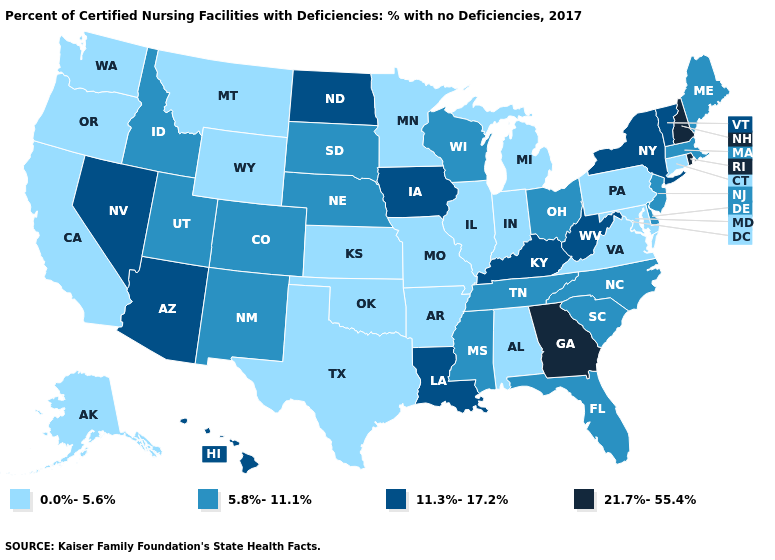Among the states that border Pennsylvania , which have the lowest value?
Quick response, please. Maryland. What is the lowest value in the USA?
Write a very short answer. 0.0%-5.6%. What is the value of West Virginia?
Keep it brief. 11.3%-17.2%. Does Alaska have the same value as Minnesota?
Be succinct. Yes. Does New York have the highest value in the Northeast?
Keep it brief. No. Which states have the lowest value in the USA?
Short answer required. Alabama, Alaska, Arkansas, California, Connecticut, Illinois, Indiana, Kansas, Maryland, Michigan, Minnesota, Missouri, Montana, Oklahoma, Oregon, Pennsylvania, Texas, Virginia, Washington, Wyoming. Name the states that have a value in the range 5.8%-11.1%?
Write a very short answer. Colorado, Delaware, Florida, Idaho, Maine, Massachusetts, Mississippi, Nebraska, New Jersey, New Mexico, North Carolina, Ohio, South Carolina, South Dakota, Tennessee, Utah, Wisconsin. What is the lowest value in the USA?
Give a very brief answer. 0.0%-5.6%. Does the map have missing data?
Be succinct. No. Does Colorado have a higher value than Texas?
Answer briefly. Yes. Does Louisiana have the highest value in the USA?
Concise answer only. No. Does South Dakota have a higher value than Kentucky?
Concise answer only. No. Name the states that have a value in the range 5.8%-11.1%?
Short answer required. Colorado, Delaware, Florida, Idaho, Maine, Massachusetts, Mississippi, Nebraska, New Jersey, New Mexico, North Carolina, Ohio, South Carolina, South Dakota, Tennessee, Utah, Wisconsin. Among the states that border California , which have the lowest value?
Be succinct. Oregon. Does New Jersey have the lowest value in the USA?
Quick response, please. No. 